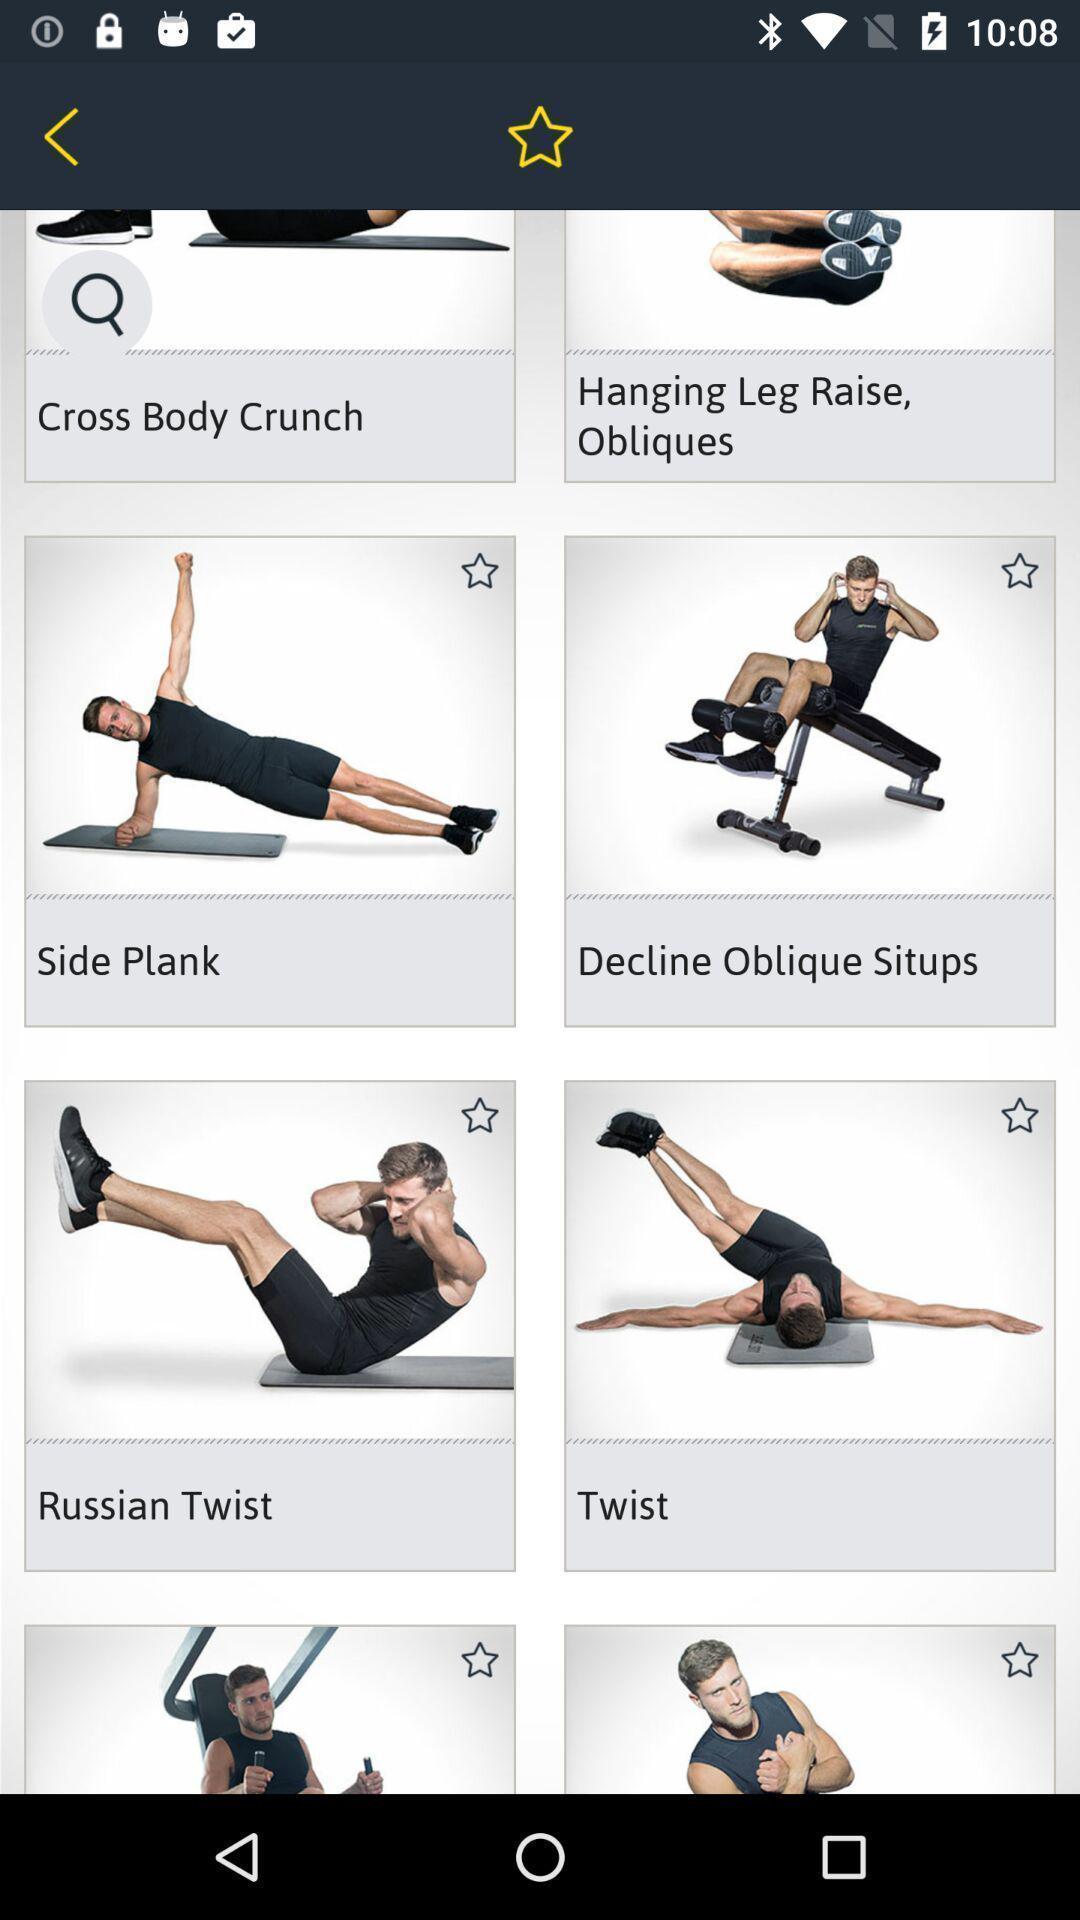Describe the content in this image. Page displaying with different type of workouts. 